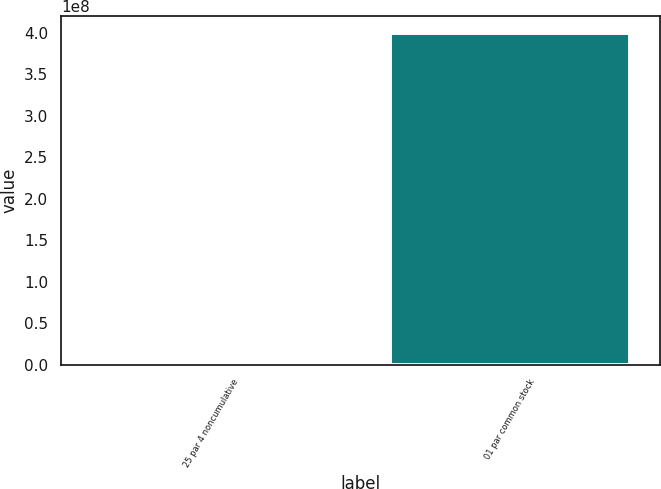<chart> <loc_0><loc_0><loc_500><loc_500><bar_chart><fcel>25 par 4 noncumulative<fcel>01 par common stock<nl><fcel>840000<fcel>4e+08<nl></chart> 